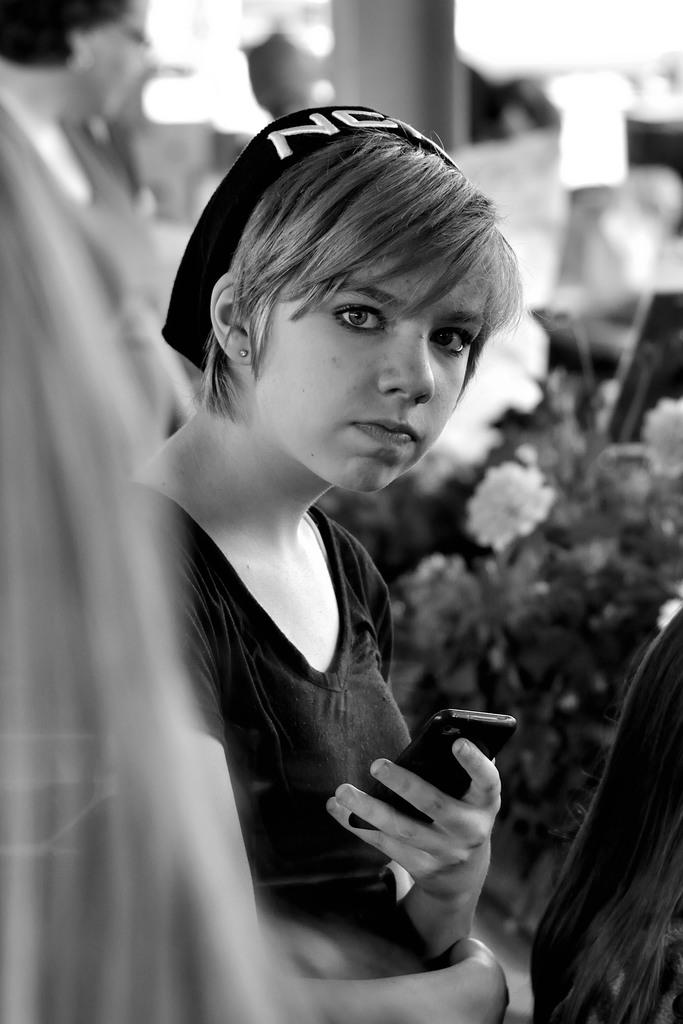Who is the main subject in the image? There is a girl in the image. What is the girl doing in the image? The girl is standing in the image. What is the girl holding in the image? The girl is holding a mobile in the image. What type of bean is the girl using to communicate in the image? There is no bean present in the image, and the girl is holding a mobile for communication. 